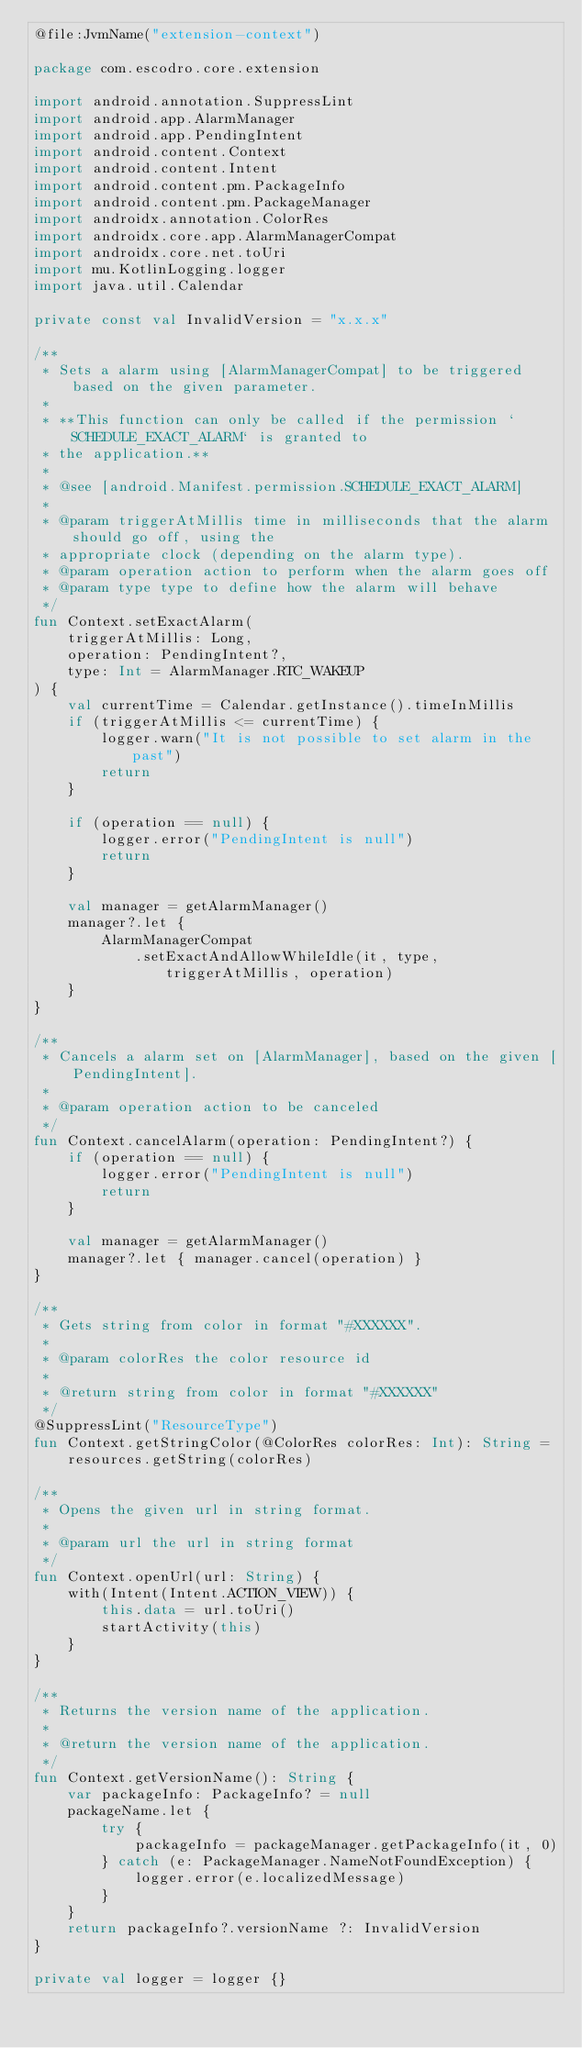Convert code to text. <code><loc_0><loc_0><loc_500><loc_500><_Kotlin_>@file:JvmName("extension-context")

package com.escodro.core.extension

import android.annotation.SuppressLint
import android.app.AlarmManager
import android.app.PendingIntent
import android.content.Context
import android.content.Intent
import android.content.pm.PackageInfo
import android.content.pm.PackageManager
import androidx.annotation.ColorRes
import androidx.core.app.AlarmManagerCompat
import androidx.core.net.toUri
import mu.KotlinLogging.logger
import java.util.Calendar

private const val InvalidVersion = "x.x.x"

/**
 * Sets a alarm using [AlarmManagerCompat] to be triggered based on the given parameter.
 *
 * **This function can only be called if the permission `SCHEDULE_EXACT_ALARM` is granted to
 * the application.**
 *
 * @see [android.Manifest.permission.SCHEDULE_EXACT_ALARM]
 *
 * @param triggerAtMillis time in milliseconds that the alarm should go off, using the
 * appropriate clock (depending on the alarm type).
 * @param operation action to perform when the alarm goes off
 * @param type type to define how the alarm will behave
 */
fun Context.setExactAlarm(
    triggerAtMillis: Long,
    operation: PendingIntent?,
    type: Int = AlarmManager.RTC_WAKEUP
) {
    val currentTime = Calendar.getInstance().timeInMillis
    if (triggerAtMillis <= currentTime) {
        logger.warn("It is not possible to set alarm in the past")
        return
    }

    if (operation == null) {
        logger.error("PendingIntent is null")
        return
    }

    val manager = getAlarmManager()
    manager?.let {
        AlarmManagerCompat
            .setExactAndAllowWhileIdle(it, type, triggerAtMillis, operation)
    }
}

/**
 * Cancels a alarm set on [AlarmManager], based on the given [PendingIntent].
 *
 * @param operation action to be canceled
 */
fun Context.cancelAlarm(operation: PendingIntent?) {
    if (operation == null) {
        logger.error("PendingIntent is null")
        return
    }

    val manager = getAlarmManager()
    manager?.let { manager.cancel(operation) }
}

/**
 * Gets string from color in format "#XXXXXX".
 *
 * @param colorRes the color resource id
 *
 * @return string from color in format "#XXXXXX"
 */
@SuppressLint("ResourceType")
fun Context.getStringColor(@ColorRes colorRes: Int): String =
    resources.getString(colorRes)

/**
 * Opens the given url in string format.
 *
 * @param url the url in string format
 */
fun Context.openUrl(url: String) {
    with(Intent(Intent.ACTION_VIEW)) {
        this.data = url.toUri()
        startActivity(this)
    }
}

/**
 * Returns the version name of the application.
 *
 * @return the version name of the application.
 */
fun Context.getVersionName(): String {
    var packageInfo: PackageInfo? = null
    packageName.let {
        try {
            packageInfo = packageManager.getPackageInfo(it, 0)
        } catch (e: PackageManager.NameNotFoundException) {
            logger.error(e.localizedMessage)
        }
    }
    return packageInfo?.versionName ?: InvalidVersion
}

private val logger = logger {}
</code> 